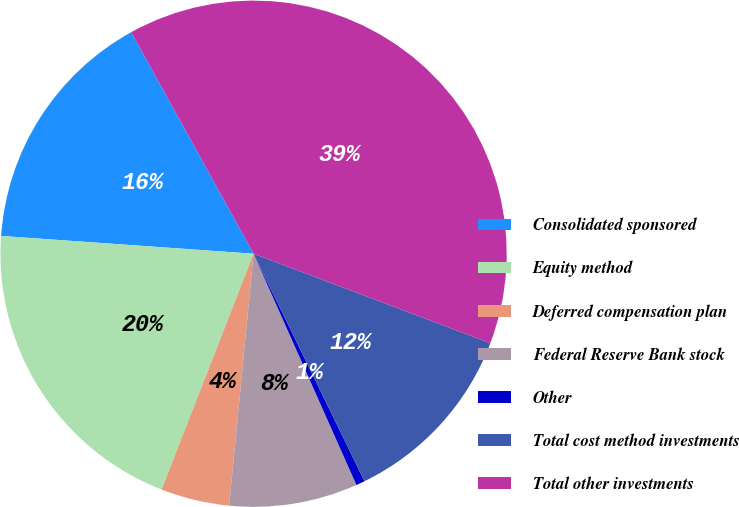Convert chart. <chart><loc_0><loc_0><loc_500><loc_500><pie_chart><fcel>Consolidated sponsored<fcel>Equity method<fcel>Deferred compensation plan<fcel>Federal Reserve Bank stock<fcel>Other<fcel>Total cost method investments<fcel>Total other investments<nl><fcel>15.85%<fcel>20.2%<fcel>4.38%<fcel>8.2%<fcel>0.56%<fcel>12.03%<fcel>38.78%<nl></chart> 